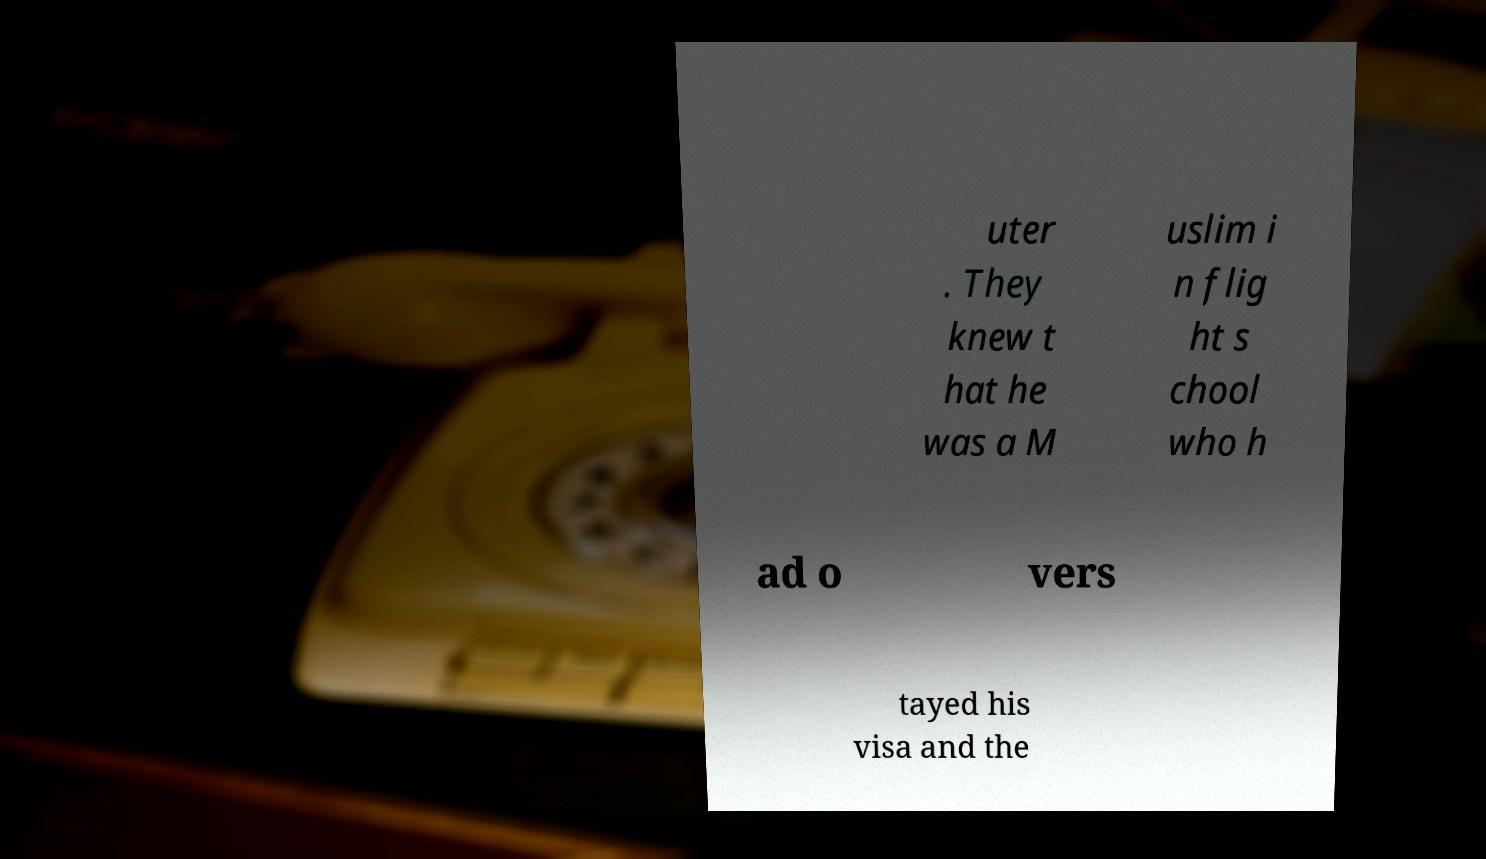Can you accurately transcribe the text from the provided image for me? uter . They knew t hat he was a M uslim i n flig ht s chool who h ad o vers tayed his visa and the 